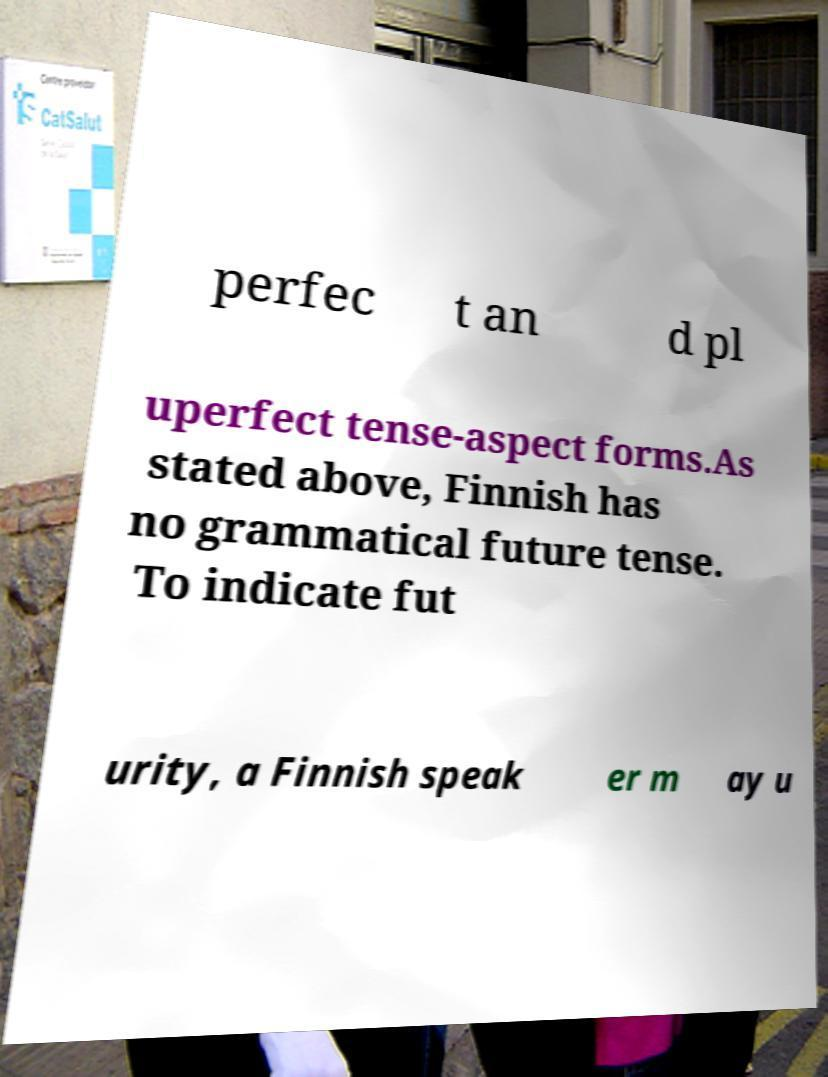What messages or text are displayed in this image? I need them in a readable, typed format. perfec t an d pl uperfect tense-aspect forms.As stated above, Finnish has no grammatical future tense. To indicate fut urity, a Finnish speak er m ay u 